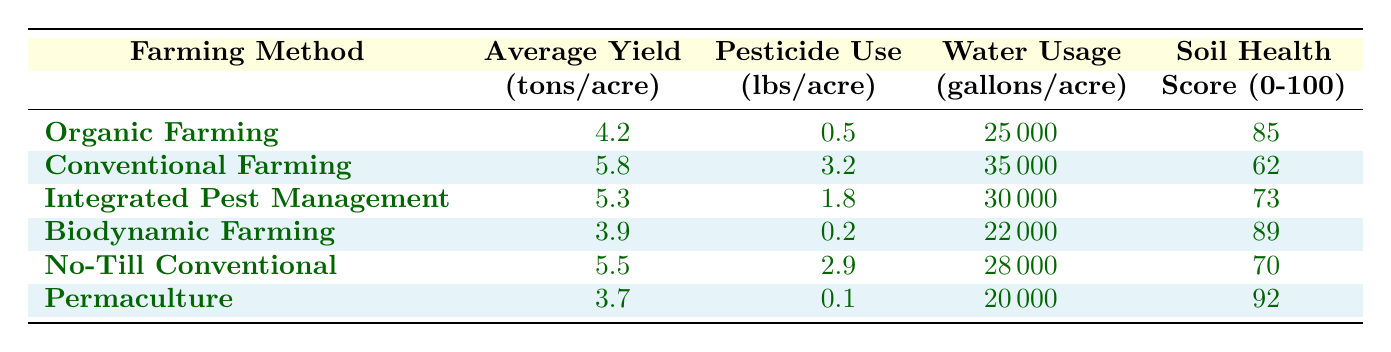What is the average yield for organic farming? The table shows that the average yield for organic farming is listed as 4.2 tons per acre.
Answer: 4.2 Which farming method uses the least amount of pesticide? The table indicates that biodynamic farming has the least pesticide use at 0.2 lbs per acre.
Answer: 0.2 What is the difference in water usage between conventional and organic farming? Conventional farming uses 35,000 gallons per acre, while organic farming uses 25,000 gallons per acre. The difference is 35,000 - 25,000 = 10,000 gallons.
Answer: 10,000 Is it true that integrated pest management has a higher soil health score than conventional farming? The soil health score for integrated pest management is 73, while for conventional farming it is 62. Therefore, it is true that integrated pest management has a higher score.
Answer: Yes What is the average soil health score for all farming methods listed? To find the average soil health score, we add the scores: 85 (organic) + 62 (conventional) + 73 (IPM) + 89 (biodynamic) + 70 (no-till) + 92 (permaculture) = 471. Then, we divide by 6 (the number of farming methods): 471 / 6 = 78.5.
Answer: 78.5 